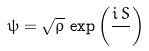<formula> <loc_0><loc_0><loc_500><loc_500>\psi = { \sqrt { \rho } } \, \exp \left ( { \frac { i \, S } { } } \right )</formula> 